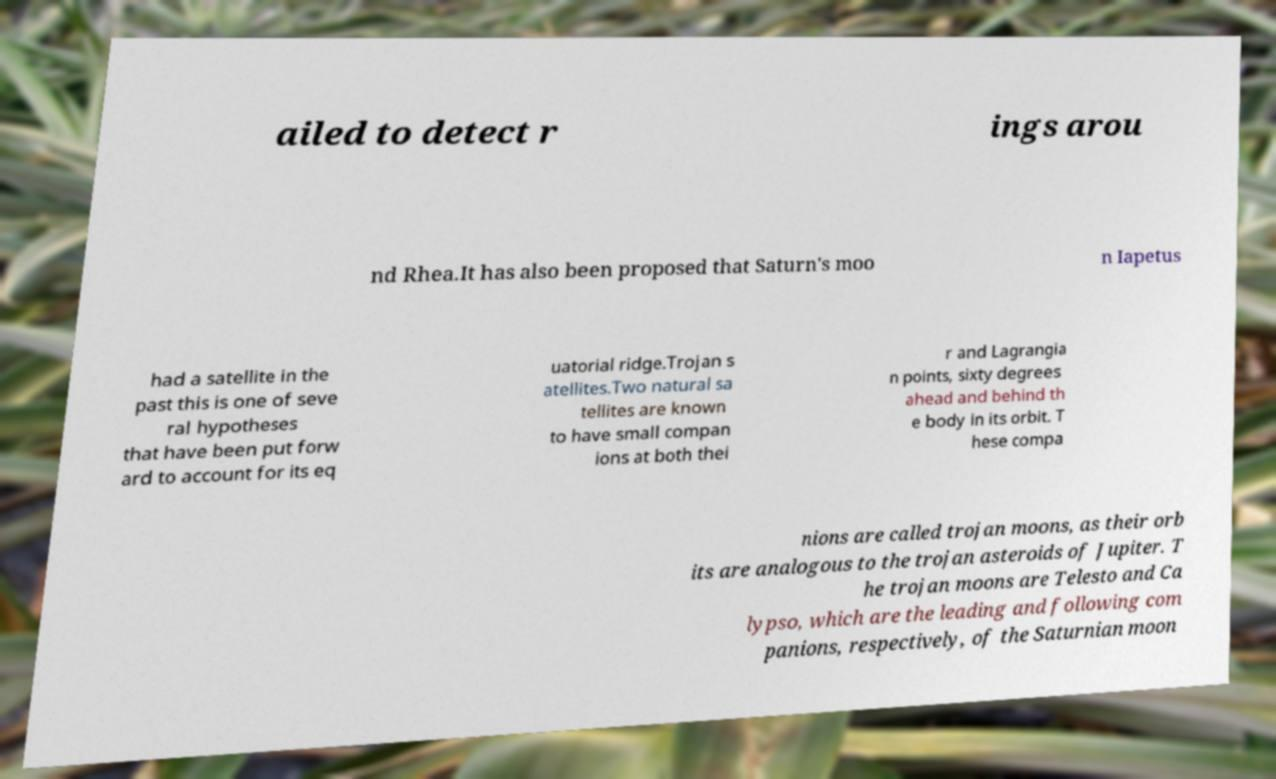There's text embedded in this image that I need extracted. Can you transcribe it verbatim? ailed to detect r ings arou nd Rhea.It has also been proposed that Saturn's moo n Iapetus had a satellite in the past this is one of seve ral hypotheses that have been put forw ard to account for its eq uatorial ridge.Trojan s atellites.Two natural sa tellites are known to have small compan ions at both thei r and Lagrangia n points, sixty degrees ahead and behind th e body in its orbit. T hese compa nions are called trojan moons, as their orb its are analogous to the trojan asteroids of Jupiter. T he trojan moons are Telesto and Ca lypso, which are the leading and following com panions, respectively, of the Saturnian moon 